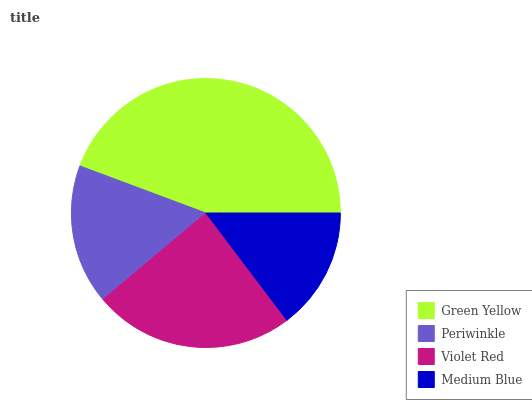Is Medium Blue the minimum?
Answer yes or no. Yes. Is Green Yellow the maximum?
Answer yes or no. Yes. Is Periwinkle the minimum?
Answer yes or no. No. Is Periwinkle the maximum?
Answer yes or no. No. Is Green Yellow greater than Periwinkle?
Answer yes or no. Yes. Is Periwinkle less than Green Yellow?
Answer yes or no. Yes. Is Periwinkle greater than Green Yellow?
Answer yes or no. No. Is Green Yellow less than Periwinkle?
Answer yes or no. No. Is Violet Red the high median?
Answer yes or no. Yes. Is Periwinkle the low median?
Answer yes or no. Yes. Is Green Yellow the high median?
Answer yes or no. No. Is Medium Blue the low median?
Answer yes or no. No. 